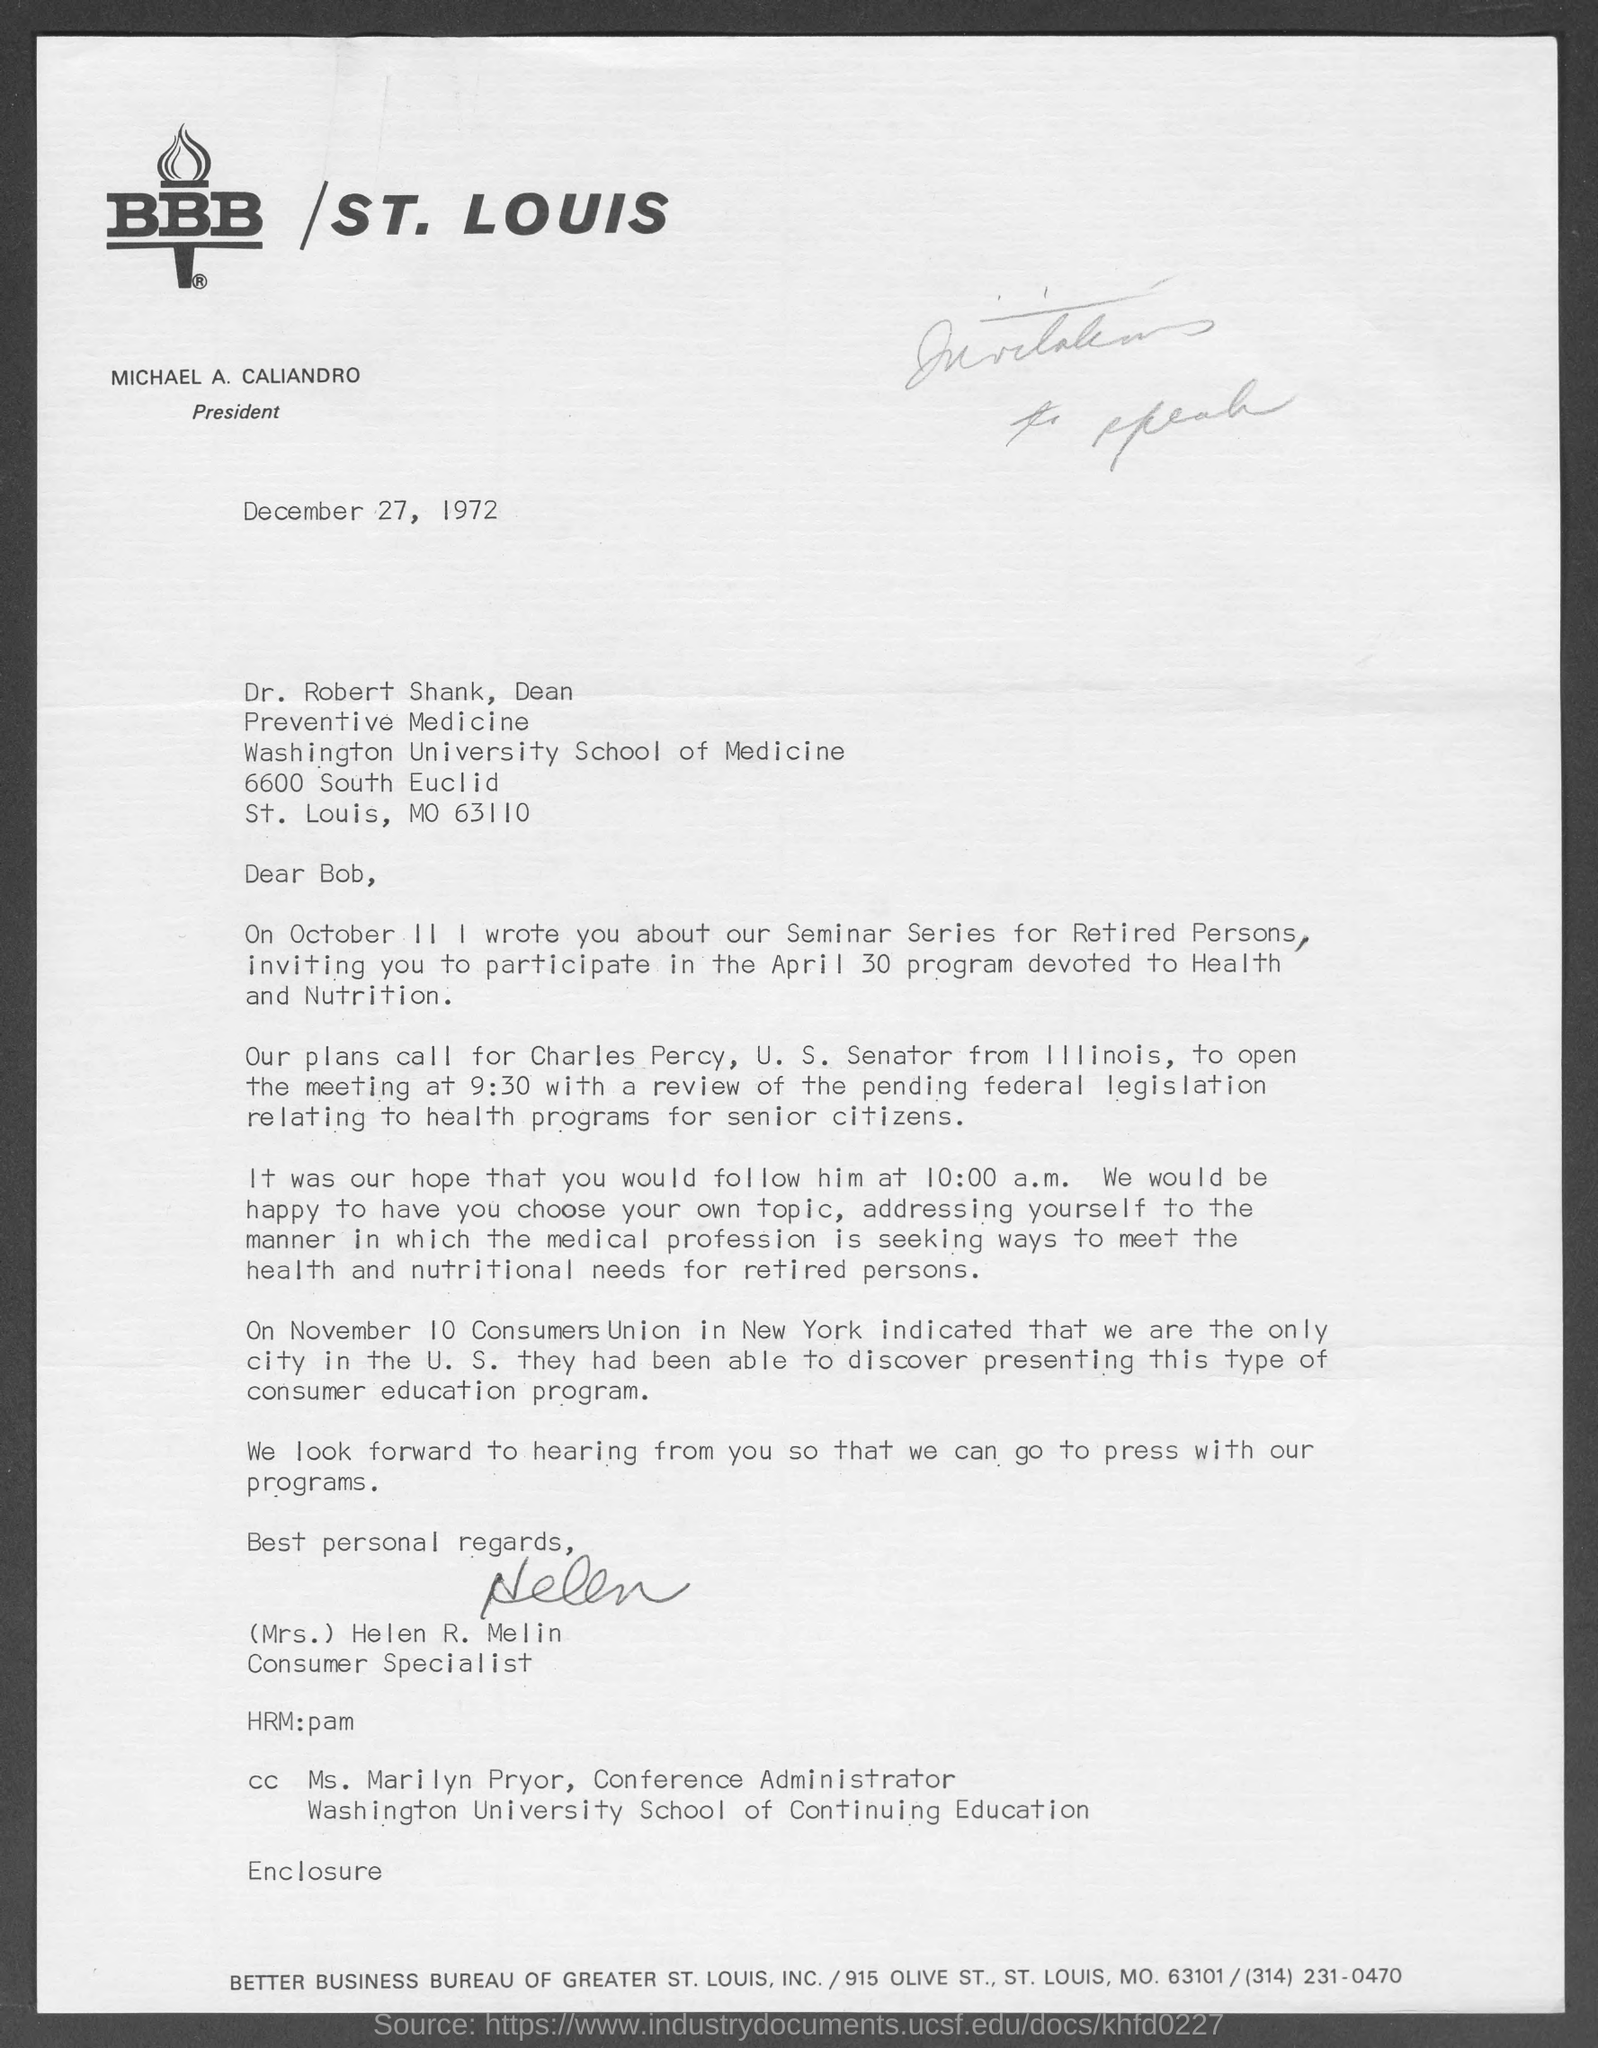List a handful of essential elements in this visual. The MO of St. Louis is 63110. Dr. Robert Shank is the dean of preventive medicine. The conference administrator at the Washington University School of Continuing Studies is Ms. Marilyn Pryor. It is confirmed that Michael A. Caliandro is the current president of St. Louis. The date that the letter is written on is December 27, 1972. 